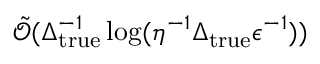<formula> <loc_0><loc_0><loc_500><loc_500>\tilde { \mathcal { O } } ( \Delta _ { t r u e } ^ { - 1 } \log ( \eta ^ { - 1 } \Delta _ { t r u e } \epsilon ^ { - 1 } ) )</formula> 